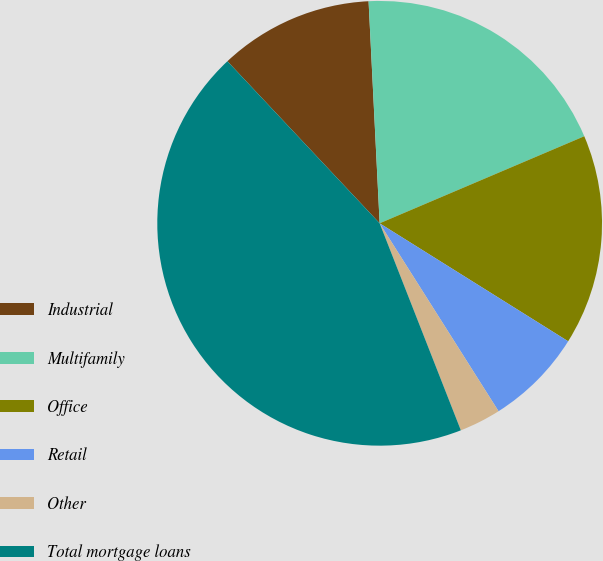Convert chart. <chart><loc_0><loc_0><loc_500><loc_500><pie_chart><fcel>Industrial<fcel>Multifamily<fcel>Office<fcel>Retail<fcel>Other<fcel>Total mortgage loans<nl><fcel>11.21%<fcel>19.39%<fcel>15.3%<fcel>7.12%<fcel>3.03%<fcel>43.94%<nl></chart> 